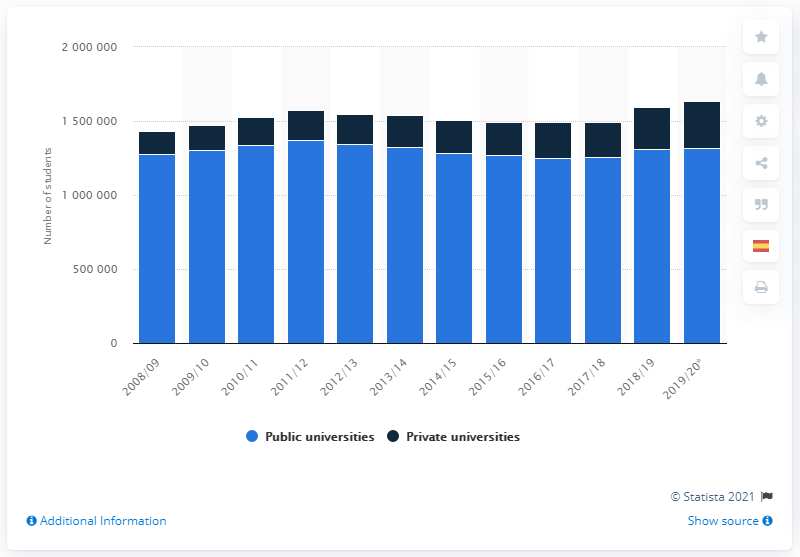Identify some key points in this picture. In the academic year 2012/13, a public university had a total of 1,371,355 registered students. The number of students who were enrolled at private universities during the academic year 2019/20 was 318,783. During the 2018/19 academic year, a public university had a total of 131,1800 registered students. 